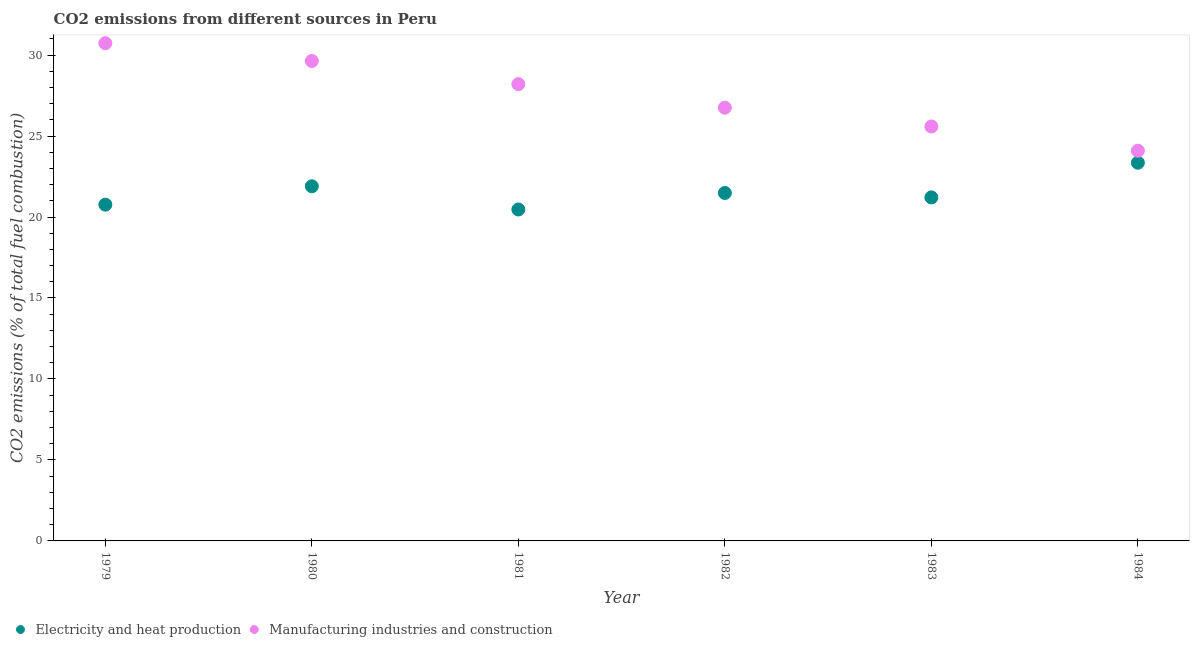How many different coloured dotlines are there?
Provide a short and direct response. 2. What is the co2 emissions due to electricity and heat production in 1984?
Keep it short and to the point. 23.35. Across all years, what is the maximum co2 emissions due to manufacturing industries?
Offer a very short reply. 30.73. Across all years, what is the minimum co2 emissions due to electricity and heat production?
Ensure brevity in your answer.  20.47. In which year was the co2 emissions due to electricity and heat production maximum?
Ensure brevity in your answer.  1984. What is the total co2 emissions due to electricity and heat production in the graph?
Provide a succinct answer. 129.18. What is the difference between the co2 emissions due to manufacturing industries in 1981 and that in 1984?
Provide a succinct answer. 4.11. What is the difference between the co2 emissions due to electricity and heat production in 1979 and the co2 emissions due to manufacturing industries in 1983?
Ensure brevity in your answer.  -4.82. What is the average co2 emissions due to electricity and heat production per year?
Give a very brief answer. 21.53. In the year 1979, what is the difference between the co2 emissions due to electricity and heat production and co2 emissions due to manufacturing industries?
Make the answer very short. -9.97. What is the ratio of the co2 emissions due to electricity and heat production in 1980 to that in 1984?
Your response must be concise. 0.94. What is the difference between the highest and the second highest co2 emissions due to manufacturing industries?
Provide a short and direct response. 1.1. What is the difference between the highest and the lowest co2 emissions due to electricity and heat production?
Your answer should be very brief. 2.88. In how many years, is the co2 emissions due to electricity and heat production greater than the average co2 emissions due to electricity and heat production taken over all years?
Give a very brief answer. 2. Is the sum of the co2 emissions due to electricity and heat production in 1983 and 1984 greater than the maximum co2 emissions due to manufacturing industries across all years?
Offer a very short reply. Yes. Does the co2 emissions due to electricity and heat production monotonically increase over the years?
Make the answer very short. No. Is the co2 emissions due to electricity and heat production strictly greater than the co2 emissions due to manufacturing industries over the years?
Make the answer very short. No. How many dotlines are there?
Your response must be concise. 2. How many years are there in the graph?
Make the answer very short. 6. What is the difference between two consecutive major ticks on the Y-axis?
Keep it short and to the point. 5. Are the values on the major ticks of Y-axis written in scientific E-notation?
Your response must be concise. No. Does the graph contain grids?
Keep it short and to the point. No. Where does the legend appear in the graph?
Make the answer very short. Bottom left. How are the legend labels stacked?
Your response must be concise. Horizontal. What is the title of the graph?
Give a very brief answer. CO2 emissions from different sources in Peru. What is the label or title of the Y-axis?
Make the answer very short. CO2 emissions (% of total fuel combustion). What is the CO2 emissions (% of total fuel combustion) of Electricity and heat production in 1979?
Your answer should be very brief. 20.76. What is the CO2 emissions (% of total fuel combustion) in Manufacturing industries and construction in 1979?
Your answer should be compact. 30.73. What is the CO2 emissions (% of total fuel combustion) of Electricity and heat production in 1980?
Give a very brief answer. 21.9. What is the CO2 emissions (% of total fuel combustion) in Manufacturing industries and construction in 1980?
Your response must be concise. 29.64. What is the CO2 emissions (% of total fuel combustion) in Electricity and heat production in 1981?
Give a very brief answer. 20.47. What is the CO2 emissions (% of total fuel combustion) of Manufacturing industries and construction in 1981?
Give a very brief answer. 28.21. What is the CO2 emissions (% of total fuel combustion) in Electricity and heat production in 1982?
Make the answer very short. 21.49. What is the CO2 emissions (% of total fuel combustion) of Manufacturing industries and construction in 1982?
Your answer should be very brief. 26.75. What is the CO2 emissions (% of total fuel combustion) of Electricity and heat production in 1983?
Give a very brief answer. 21.21. What is the CO2 emissions (% of total fuel combustion) in Manufacturing industries and construction in 1983?
Provide a short and direct response. 25.59. What is the CO2 emissions (% of total fuel combustion) in Electricity and heat production in 1984?
Your response must be concise. 23.35. What is the CO2 emissions (% of total fuel combustion) in Manufacturing industries and construction in 1984?
Make the answer very short. 24.1. Across all years, what is the maximum CO2 emissions (% of total fuel combustion) of Electricity and heat production?
Keep it short and to the point. 23.35. Across all years, what is the maximum CO2 emissions (% of total fuel combustion) of Manufacturing industries and construction?
Offer a very short reply. 30.73. Across all years, what is the minimum CO2 emissions (% of total fuel combustion) of Electricity and heat production?
Make the answer very short. 20.47. Across all years, what is the minimum CO2 emissions (% of total fuel combustion) in Manufacturing industries and construction?
Offer a terse response. 24.1. What is the total CO2 emissions (% of total fuel combustion) of Electricity and heat production in the graph?
Ensure brevity in your answer.  129.18. What is the total CO2 emissions (% of total fuel combustion) in Manufacturing industries and construction in the graph?
Provide a succinct answer. 165.01. What is the difference between the CO2 emissions (% of total fuel combustion) in Electricity and heat production in 1979 and that in 1980?
Give a very brief answer. -1.13. What is the difference between the CO2 emissions (% of total fuel combustion) in Manufacturing industries and construction in 1979 and that in 1980?
Keep it short and to the point. 1.1. What is the difference between the CO2 emissions (% of total fuel combustion) of Electricity and heat production in 1979 and that in 1981?
Your answer should be compact. 0.3. What is the difference between the CO2 emissions (% of total fuel combustion) of Manufacturing industries and construction in 1979 and that in 1981?
Offer a very short reply. 2.53. What is the difference between the CO2 emissions (% of total fuel combustion) in Electricity and heat production in 1979 and that in 1982?
Ensure brevity in your answer.  -0.72. What is the difference between the CO2 emissions (% of total fuel combustion) of Manufacturing industries and construction in 1979 and that in 1982?
Your response must be concise. 3.98. What is the difference between the CO2 emissions (% of total fuel combustion) in Electricity and heat production in 1979 and that in 1983?
Keep it short and to the point. -0.45. What is the difference between the CO2 emissions (% of total fuel combustion) in Manufacturing industries and construction in 1979 and that in 1983?
Your response must be concise. 5.14. What is the difference between the CO2 emissions (% of total fuel combustion) of Electricity and heat production in 1979 and that in 1984?
Provide a short and direct response. -2.59. What is the difference between the CO2 emissions (% of total fuel combustion) in Manufacturing industries and construction in 1979 and that in 1984?
Your answer should be very brief. 6.64. What is the difference between the CO2 emissions (% of total fuel combustion) in Electricity and heat production in 1980 and that in 1981?
Offer a terse response. 1.43. What is the difference between the CO2 emissions (% of total fuel combustion) in Manufacturing industries and construction in 1980 and that in 1981?
Make the answer very short. 1.43. What is the difference between the CO2 emissions (% of total fuel combustion) of Electricity and heat production in 1980 and that in 1982?
Your response must be concise. 0.41. What is the difference between the CO2 emissions (% of total fuel combustion) of Manufacturing industries and construction in 1980 and that in 1982?
Provide a short and direct response. 2.88. What is the difference between the CO2 emissions (% of total fuel combustion) in Electricity and heat production in 1980 and that in 1983?
Provide a short and direct response. 0.69. What is the difference between the CO2 emissions (% of total fuel combustion) in Manufacturing industries and construction in 1980 and that in 1983?
Make the answer very short. 4.05. What is the difference between the CO2 emissions (% of total fuel combustion) in Electricity and heat production in 1980 and that in 1984?
Give a very brief answer. -1.45. What is the difference between the CO2 emissions (% of total fuel combustion) in Manufacturing industries and construction in 1980 and that in 1984?
Give a very brief answer. 5.54. What is the difference between the CO2 emissions (% of total fuel combustion) in Electricity and heat production in 1981 and that in 1982?
Keep it short and to the point. -1.02. What is the difference between the CO2 emissions (% of total fuel combustion) of Manufacturing industries and construction in 1981 and that in 1982?
Your response must be concise. 1.45. What is the difference between the CO2 emissions (% of total fuel combustion) in Electricity and heat production in 1981 and that in 1983?
Keep it short and to the point. -0.75. What is the difference between the CO2 emissions (% of total fuel combustion) in Manufacturing industries and construction in 1981 and that in 1983?
Your answer should be compact. 2.62. What is the difference between the CO2 emissions (% of total fuel combustion) of Electricity and heat production in 1981 and that in 1984?
Provide a short and direct response. -2.88. What is the difference between the CO2 emissions (% of total fuel combustion) in Manufacturing industries and construction in 1981 and that in 1984?
Provide a succinct answer. 4.11. What is the difference between the CO2 emissions (% of total fuel combustion) in Electricity and heat production in 1982 and that in 1983?
Provide a succinct answer. 0.27. What is the difference between the CO2 emissions (% of total fuel combustion) in Manufacturing industries and construction in 1982 and that in 1983?
Provide a short and direct response. 1.16. What is the difference between the CO2 emissions (% of total fuel combustion) in Electricity and heat production in 1982 and that in 1984?
Make the answer very short. -1.87. What is the difference between the CO2 emissions (% of total fuel combustion) in Manufacturing industries and construction in 1982 and that in 1984?
Ensure brevity in your answer.  2.66. What is the difference between the CO2 emissions (% of total fuel combustion) in Electricity and heat production in 1983 and that in 1984?
Offer a very short reply. -2.14. What is the difference between the CO2 emissions (% of total fuel combustion) in Manufacturing industries and construction in 1983 and that in 1984?
Offer a very short reply. 1.49. What is the difference between the CO2 emissions (% of total fuel combustion) in Electricity and heat production in 1979 and the CO2 emissions (% of total fuel combustion) in Manufacturing industries and construction in 1980?
Ensure brevity in your answer.  -8.87. What is the difference between the CO2 emissions (% of total fuel combustion) of Electricity and heat production in 1979 and the CO2 emissions (% of total fuel combustion) of Manufacturing industries and construction in 1981?
Provide a succinct answer. -7.44. What is the difference between the CO2 emissions (% of total fuel combustion) in Electricity and heat production in 1979 and the CO2 emissions (% of total fuel combustion) in Manufacturing industries and construction in 1982?
Make the answer very short. -5.99. What is the difference between the CO2 emissions (% of total fuel combustion) of Electricity and heat production in 1979 and the CO2 emissions (% of total fuel combustion) of Manufacturing industries and construction in 1983?
Make the answer very short. -4.82. What is the difference between the CO2 emissions (% of total fuel combustion) of Electricity and heat production in 1979 and the CO2 emissions (% of total fuel combustion) of Manufacturing industries and construction in 1984?
Give a very brief answer. -3.33. What is the difference between the CO2 emissions (% of total fuel combustion) of Electricity and heat production in 1980 and the CO2 emissions (% of total fuel combustion) of Manufacturing industries and construction in 1981?
Ensure brevity in your answer.  -6.31. What is the difference between the CO2 emissions (% of total fuel combustion) of Electricity and heat production in 1980 and the CO2 emissions (% of total fuel combustion) of Manufacturing industries and construction in 1982?
Your answer should be very brief. -4.85. What is the difference between the CO2 emissions (% of total fuel combustion) of Electricity and heat production in 1980 and the CO2 emissions (% of total fuel combustion) of Manufacturing industries and construction in 1983?
Your answer should be very brief. -3.69. What is the difference between the CO2 emissions (% of total fuel combustion) in Electricity and heat production in 1980 and the CO2 emissions (% of total fuel combustion) in Manufacturing industries and construction in 1984?
Offer a terse response. -2.2. What is the difference between the CO2 emissions (% of total fuel combustion) of Electricity and heat production in 1981 and the CO2 emissions (% of total fuel combustion) of Manufacturing industries and construction in 1982?
Make the answer very short. -6.29. What is the difference between the CO2 emissions (% of total fuel combustion) of Electricity and heat production in 1981 and the CO2 emissions (% of total fuel combustion) of Manufacturing industries and construction in 1983?
Offer a terse response. -5.12. What is the difference between the CO2 emissions (% of total fuel combustion) of Electricity and heat production in 1981 and the CO2 emissions (% of total fuel combustion) of Manufacturing industries and construction in 1984?
Make the answer very short. -3.63. What is the difference between the CO2 emissions (% of total fuel combustion) of Electricity and heat production in 1982 and the CO2 emissions (% of total fuel combustion) of Manufacturing industries and construction in 1983?
Provide a short and direct response. -4.1. What is the difference between the CO2 emissions (% of total fuel combustion) in Electricity and heat production in 1982 and the CO2 emissions (% of total fuel combustion) in Manufacturing industries and construction in 1984?
Your answer should be very brief. -2.61. What is the difference between the CO2 emissions (% of total fuel combustion) of Electricity and heat production in 1983 and the CO2 emissions (% of total fuel combustion) of Manufacturing industries and construction in 1984?
Your answer should be compact. -2.88. What is the average CO2 emissions (% of total fuel combustion) of Electricity and heat production per year?
Your response must be concise. 21.53. What is the average CO2 emissions (% of total fuel combustion) in Manufacturing industries and construction per year?
Your answer should be very brief. 27.5. In the year 1979, what is the difference between the CO2 emissions (% of total fuel combustion) in Electricity and heat production and CO2 emissions (% of total fuel combustion) in Manufacturing industries and construction?
Make the answer very short. -9.97. In the year 1980, what is the difference between the CO2 emissions (% of total fuel combustion) of Electricity and heat production and CO2 emissions (% of total fuel combustion) of Manufacturing industries and construction?
Offer a terse response. -7.74. In the year 1981, what is the difference between the CO2 emissions (% of total fuel combustion) of Electricity and heat production and CO2 emissions (% of total fuel combustion) of Manufacturing industries and construction?
Your response must be concise. -7.74. In the year 1982, what is the difference between the CO2 emissions (% of total fuel combustion) of Electricity and heat production and CO2 emissions (% of total fuel combustion) of Manufacturing industries and construction?
Provide a succinct answer. -5.27. In the year 1983, what is the difference between the CO2 emissions (% of total fuel combustion) in Electricity and heat production and CO2 emissions (% of total fuel combustion) in Manufacturing industries and construction?
Your answer should be very brief. -4.38. In the year 1984, what is the difference between the CO2 emissions (% of total fuel combustion) in Electricity and heat production and CO2 emissions (% of total fuel combustion) in Manufacturing industries and construction?
Keep it short and to the point. -0.74. What is the ratio of the CO2 emissions (% of total fuel combustion) in Electricity and heat production in 1979 to that in 1980?
Offer a terse response. 0.95. What is the ratio of the CO2 emissions (% of total fuel combustion) of Manufacturing industries and construction in 1979 to that in 1980?
Give a very brief answer. 1.04. What is the ratio of the CO2 emissions (% of total fuel combustion) of Electricity and heat production in 1979 to that in 1981?
Provide a short and direct response. 1.01. What is the ratio of the CO2 emissions (% of total fuel combustion) of Manufacturing industries and construction in 1979 to that in 1981?
Keep it short and to the point. 1.09. What is the ratio of the CO2 emissions (% of total fuel combustion) in Electricity and heat production in 1979 to that in 1982?
Offer a terse response. 0.97. What is the ratio of the CO2 emissions (% of total fuel combustion) in Manufacturing industries and construction in 1979 to that in 1982?
Ensure brevity in your answer.  1.15. What is the ratio of the CO2 emissions (% of total fuel combustion) in Electricity and heat production in 1979 to that in 1983?
Your response must be concise. 0.98. What is the ratio of the CO2 emissions (% of total fuel combustion) of Manufacturing industries and construction in 1979 to that in 1983?
Keep it short and to the point. 1.2. What is the ratio of the CO2 emissions (% of total fuel combustion) of Electricity and heat production in 1979 to that in 1984?
Keep it short and to the point. 0.89. What is the ratio of the CO2 emissions (% of total fuel combustion) of Manufacturing industries and construction in 1979 to that in 1984?
Your answer should be compact. 1.28. What is the ratio of the CO2 emissions (% of total fuel combustion) in Electricity and heat production in 1980 to that in 1981?
Ensure brevity in your answer.  1.07. What is the ratio of the CO2 emissions (% of total fuel combustion) in Manufacturing industries and construction in 1980 to that in 1981?
Offer a very short reply. 1.05. What is the ratio of the CO2 emissions (% of total fuel combustion) in Electricity and heat production in 1980 to that in 1982?
Your answer should be very brief. 1.02. What is the ratio of the CO2 emissions (% of total fuel combustion) of Manufacturing industries and construction in 1980 to that in 1982?
Your response must be concise. 1.11. What is the ratio of the CO2 emissions (% of total fuel combustion) in Electricity and heat production in 1980 to that in 1983?
Offer a terse response. 1.03. What is the ratio of the CO2 emissions (% of total fuel combustion) in Manufacturing industries and construction in 1980 to that in 1983?
Offer a terse response. 1.16. What is the ratio of the CO2 emissions (% of total fuel combustion) in Electricity and heat production in 1980 to that in 1984?
Offer a terse response. 0.94. What is the ratio of the CO2 emissions (% of total fuel combustion) of Manufacturing industries and construction in 1980 to that in 1984?
Ensure brevity in your answer.  1.23. What is the ratio of the CO2 emissions (% of total fuel combustion) of Electricity and heat production in 1981 to that in 1982?
Make the answer very short. 0.95. What is the ratio of the CO2 emissions (% of total fuel combustion) of Manufacturing industries and construction in 1981 to that in 1982?
Ensure brevity in your answer.  1.05. What is the ratio of the CO2 emissions (% of total fuel combustion) in Electricity and heat production in 1981 to that in 1983?
Your answer should be compact. 0.96. What is the ratio of the CO2 emissions (% of total fuel combustion) of Manufacturing industries and construction in 1981 to that in 1983?
Your response must be concise. 1.1. What is the ratio of the CO2 emissions (% of total fuel combustion) of Electricity and heat production in 1981 to that in 1984?
Give a very brief answer. 0.88. What is the ratio of the CO2 emissions (% of total fuel combustion) of Manufacturing industries and construction in 1981 to that in 1984?
Your response must be concise. 1.17. What is the ratio of the CO2 emissions (% of total fuel combustion) in Electricity and heat production in 1982 to that in 1983?
Ensure brevity in your answer.  1.01. What is the ratio of the CO2 emissions (% of total fuel combustion) of Manufacturing industries and construction in 1982 to that in 1983?
Give a very brief answer. 1.05. What is the ratio of the CO2 emissions (% of total fuel combustion) in Electricity and heat production in 1982 to that in 1984?
Ensure brevity in your answer.  0.92. What is the ratio of the CO2 emissions (% of total fuel combustion) of Manufacturing industries and construction in 1982 to that in 1984?
Ensure brevity in your answer.  1.11. What is the ratio of the CO2 emissions (% of total fuel combustion) of Electricity and heat production in 1983 to that in 1984?
Your answer should be very brief. 0.91. What is the ratio of the CO2 emissions (% of total fuel combustion) in Manufacturing industries and construction in 1983 to that in 1984?
Your answer should be compact. 1.06. What is the difference between the highest and the second highest CO2 emissions (% of total fuel combustion) of Electricity and heat production?
Your response must be concise. 1.45. What is the difference between the highest and the second highest CO2 emissions (% of total fuel combustion) of Manufacturing industries and construction?
Your answer should be very brief. 1.1. What is the difference between the highest and the lowest CO2 emissions (% of total fuel combustion) of Electricity and heat production?
Give a very brief answer. 2.88. What is the difference between the highest and the lowest CO2 emissions (% of total fuel combustion) of Manufacturing industries and construction?
Your answer should be very brief. 6.64. 